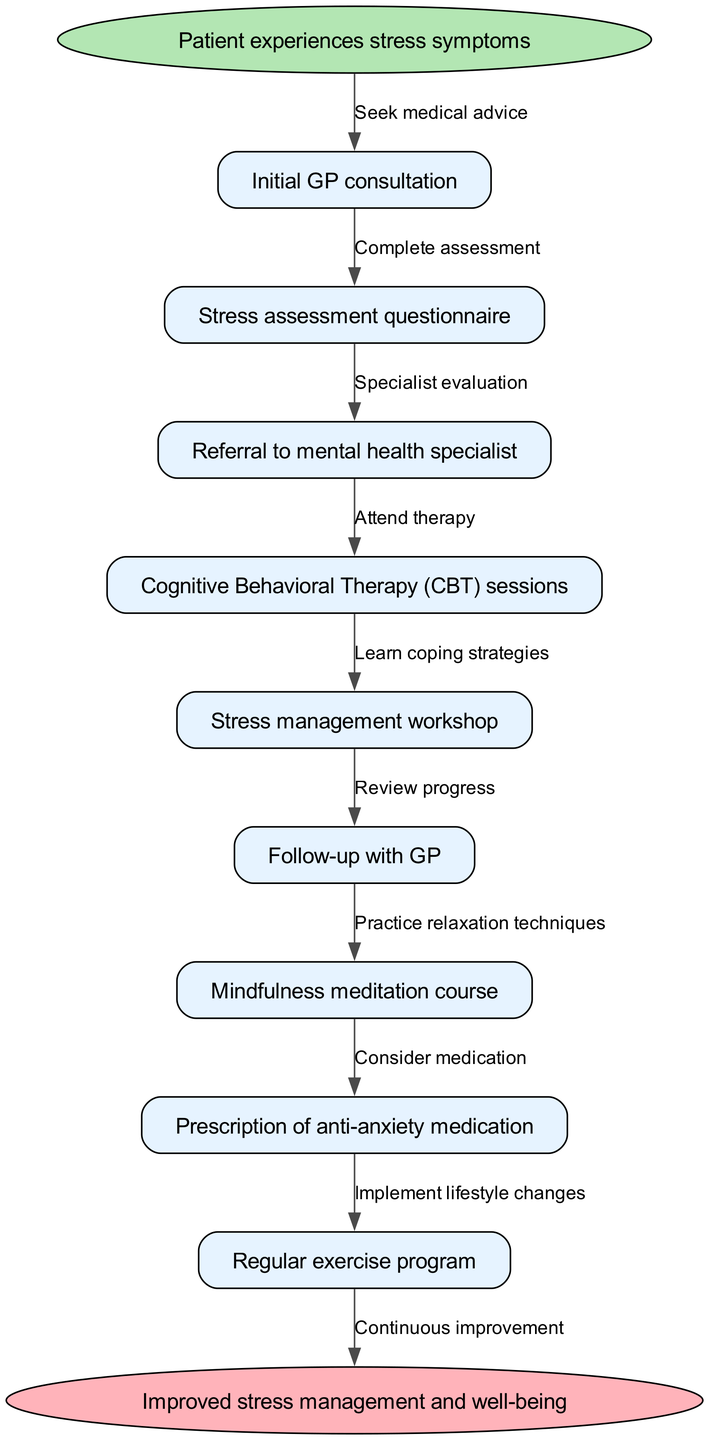What is the starting point of the patient journey? The starting point is "Patient experiences stress symptoms." This is indicated as the first node in the diagram that begins the flow of the clinical pathway.
Answer: Patient experiences stress symptoms How many nodes are present in the diagram? There are 9 nodes in total, which includes the starting point, each treatment option, and the endpoint.
Answer: 9 What is the relationship between the initial GP consultation and the stress assessment questionnaire? The relationship is that after the patient seeks medical advice, the next step is to complete a stress assessment questionnaire. This is shown as a directed edge from "Initial GP consultation" to "Stress assessment questionnaire."
Answer: Complete assessment What is the last treatment before reaching improved well-being? The last treatment before reaching "Improved stress management and well-being" is "Regular exercise program." This is identified as the final node leading to the endpoint in the pathway.
Answer: Regular exercise program Which therapy is indicated as part of this clinical pathway? The indicated therapy in the pathway is "Cognitive Behavioral Therapy (CBT) sessions." This node is specifically included as one of the main treatment steps.
Answer: Cognitive Behavioral Therapy (CBT) sessions What type of course can the patient attend to help with stress? The patient can attend a "Mindfulness meditation course." This course is mentioned as an option within the diagram to help manage stress.
Answer: Mindfulness meditation course After which node does the patient have a follow-up with the GP? The follow-up with the GP occurs after "Stress management workshop." This shows the order of steps in the pathway leading to the review of the patient's progress.
Answer: Stress management workshop What is the endpoint of the clinical pathway? The endpoint is labeled "Improved stress management and well-being." This is the ultimate goal of the clinical pathway as shown in the diagram.
Answer: Improved stress management and well-being What kind of medication might be considered during the patient journey? The medication that might be considered is "anti-anxiety medication," as indicated in one of the treatment options in the pathway.
Answer: anti-anxiety medication 